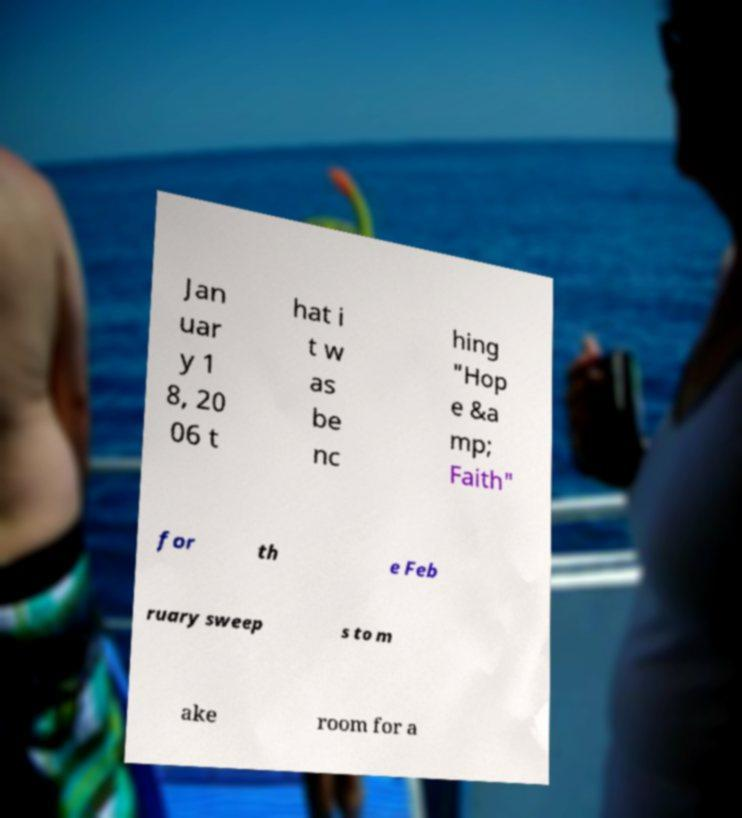Can you accurately transcribe the text from the provided image for me? Jan uar y 1 8, 20 06 t hat i t w as be nc hing "Hop e &a mp; Faith" for th e Feb ruary sweep s to m ake room for a 